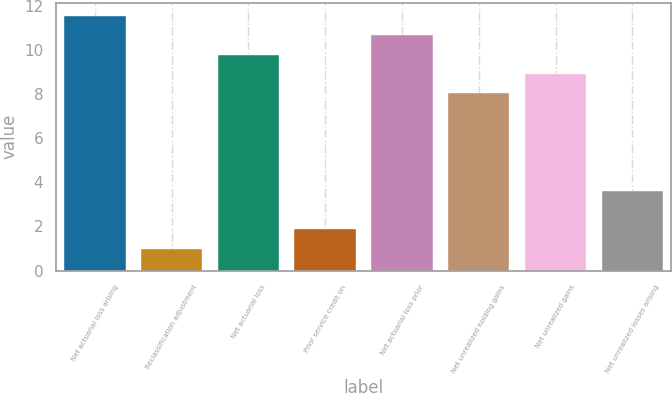Convert chart. <chart><loc_0><loc_0><loc_500><loc_500><bar_chart><fcel>Net actuarial loss arising<fcel>Reclassification adjustment<fcel>Net actuarial loss<fcel>Prior service credit on<fcel>Net actuarial loss prior<fcel>Net unrealized holding gains<fcel>Net unrealized gains<fcel>Net unrealized losses arising<nl><fcel>11.54<fcel>0.98<fcel>9.78<fcel>1.86<fcel>10.66<fcel>8.02<fcel>8.9<fcel>3.62<nl></chart> 